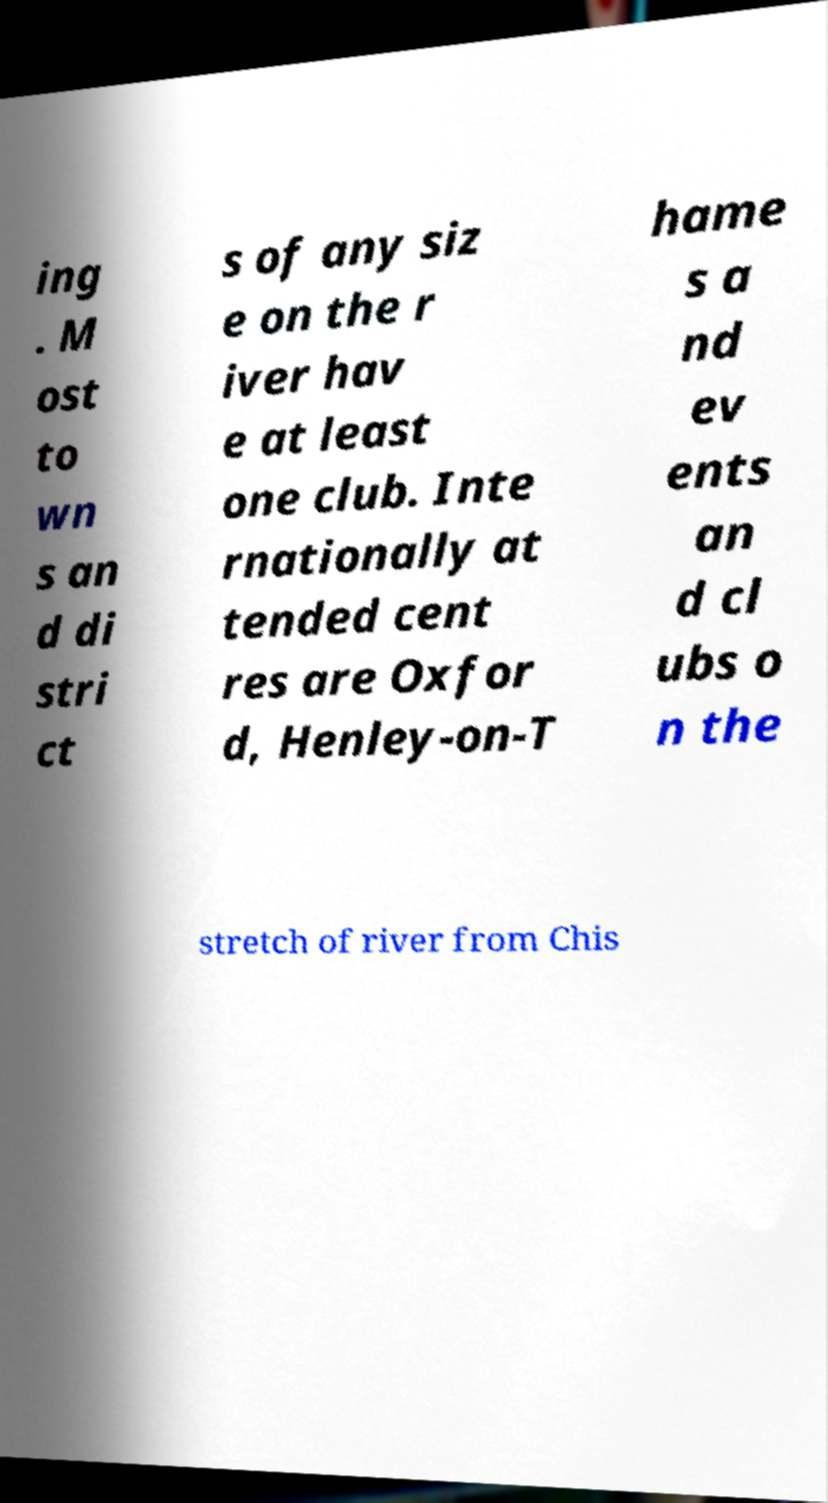Could you assist in decoding the text presented in this image and type it out clearly? ing . M ost to wn s an d di stri ct s of any siz e on the r iver hav e at least one club. Inte rnationally at tended cent res are Oxfor d, Henley-on-T hame s a nd ev ents an d cl ubs o n the stretch of river from Chis 